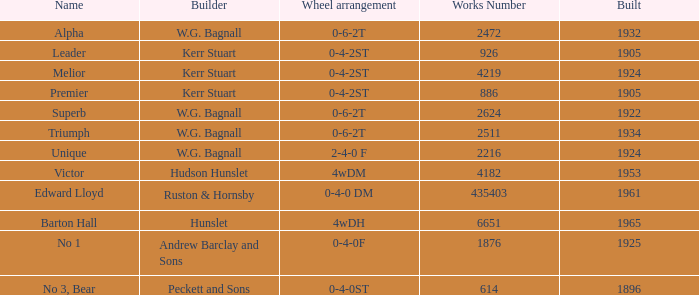What is the employment number for victor? 4182.0. 